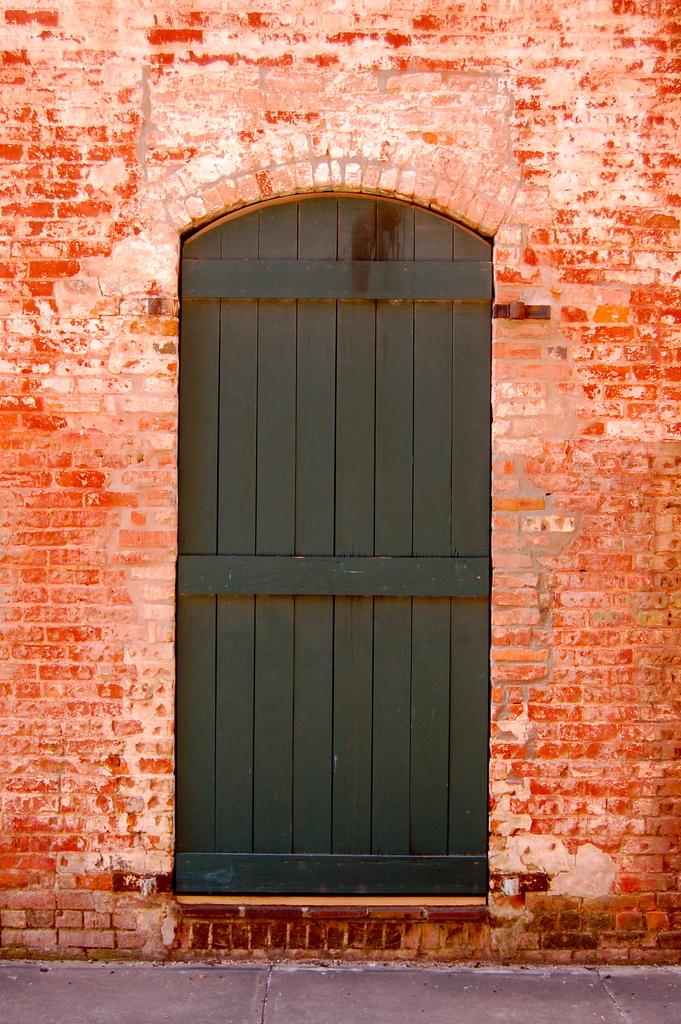What is one of the main structures visible in the image? There is a door in the image. What type of material is used to construct the wall in the image? There is a brick wall in the image. What type of air is being used by the maid in the image? There is no maid present in the image, and therefore no such activity or use of air can be observed. What subject is the person in the image learning from the door? There is no person learning from the door in the image; the door is a stationary structure. 